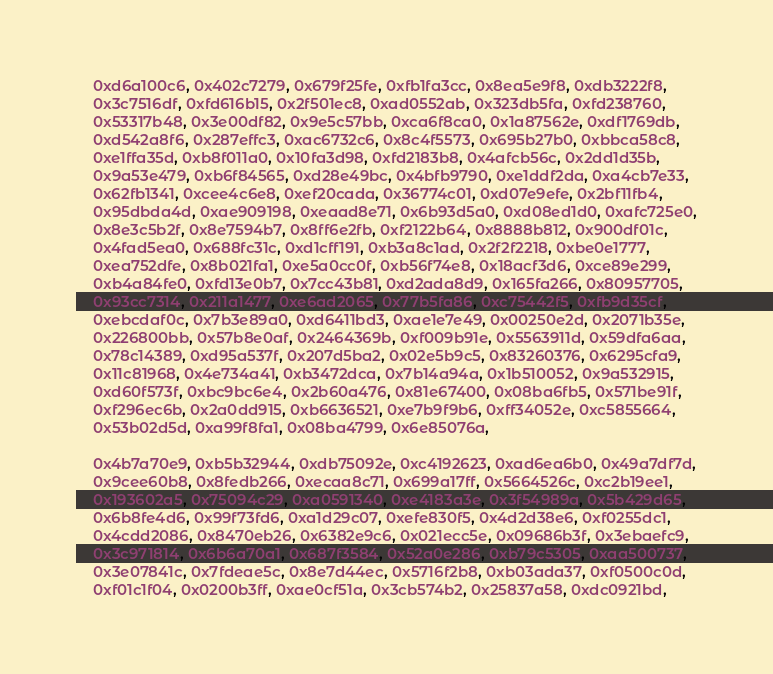Convert code to text. <code><loc_0><loc_0><loc_500><loc_500><_Crystal_>    0xd6a100c6, 0x402c7279, 0x679f25fe, 0xfb1fa3cc, 0x8ea5e9f8, 0xdb3222f8,
    0x3c7516df, 0xfd616b15, 0x2f501ec8, 0xad0552ab, 0x323db5fa, 0xfd238760,
    0x53317b48, 0x3e00df82, 0x9e5c57bb, 0xca6f8ca0, 0x1a87562e, 0xdf1769db,
    0xd542a8f6, 0x287effc3, 0xac6732c6, 0x8c4f5573, 0x695b27b0, 0xbbca58c8,
    0xe1ffa35d, 0xb8f011a0, 0x10fa3d98, 0xfd2183b8, 0x4afcb56c, 0x2dd1d35b,
    0x9a53e479, 0xb6f84565, 0xd28e49bc, 0x4bfb9790, 0xe1ddf2da, 0xa4cb7e33,
    0x62fb1341, 0xcee4c6e8, 0xef20cada, 0x36774c01, 0xd07e9efe, 0x2bf11fb4,
    0x95dbda4d, 0xae909198, 0xeaad8e71, 0x6b93d5a0, 0xd08ed1d0, 0xafc725e0,
    0x8e3c5b2f, 0x8e7594b7, 0x8ff6e2fb, 0xf2122b64, 0x8888b812, 0x900df01c,
    0x4fad5ea0, 0x688fc31c, 0xd1cff191, 0xb3a8c1ad, 0x2f2f2218, 0xbe0e1777,
    0xea752dfe, 0x8b021fa1, 0xe5a0cc0f, 0xb56f74e8, 0x18acf3d6, 0xce89e299,
    0xb4a84fe0, 0xfd13e0b7, 0x7cc43b81, 0xd2ada8d9, 0x165fa266, 0x80957705,
    0x93cc7314, 0x211a1477, 0xe6ad2065, 0x77b5fa86, 0xc75442f5, 0xfb9d35cf,
    0xebcdaf0c, 0x7b3e89a0, 0xd6411bd3, 0xae1e7e49, 0x00250e2d, 0x2071b35e,
    0x226800bb, 0x57b8e0af, 0x2464369b, 0xf009b91e, 0x5563911d, 0x59dfa6aa,
    0x78c14389, 0xd95a537f, 0x207d5ba2, 0x02e5b9c5, 0x83260376, 0x6295cfa9,
    0x11c81968, 0x4e734a41, 0xb3472dca, 0x7b14a94a, 0x1b510052, 0x9a532915,
    0xd60f573f, 0xbc9bc6e4, 0x2b60a476, 0x81e67400, 0x08ba6fb5, 0x571be91f,
    0xf296ec6b, 0x2a0dd915, 0xb6636521, 0xe7b9f9b6, 0xff34052e, 0xc5855664,
    0x53b02d5d, 0xa99f8fa1, 0x08ba4799, 0x6e85076a,

    0x4b7a70e9, 0xb5b32944, 0xdb75092e, 0xc4192623, 0xad6ea6b0, 0x49a7df7d,
    0x9cee60b8, 0x8fedb266, 0xecaa8c71, 0x699a17ff, 0x5664526c, 0xc2b19ee1,
    0x193602a5, 0x75094c29, 0xa0591340, 0xe4183a3e, 0x3f54989a, 0x5b429d65,
    0x6b8fe4d6, 0x99f73fd6, 0xa1d29c07, 0xefe830f5, 0x4d2d38e6, 0xf0255dc1,
    0x4cdd2086, 0x8470eb26, 0x6382e9c6, 0x021ecc5e, 0x09686b3f, 0x3ebaefc9,
    0x3c971814, 0x6b6a70a1, 0x687f3584, 0x52a0e286, 0xb79c5305, 0xaa500737,
    0x3e07841c, 0x7fdeae5c, 0x8e7d44ec, 0x5716f2b8, 0xb03ada37, 0xf0500c0d,
    0xf01c1f04, 0x0200b3ff, 0xae0cf51a, 0x3cb574b2, 0x25837a58, 0xdc0921bd,</code> 